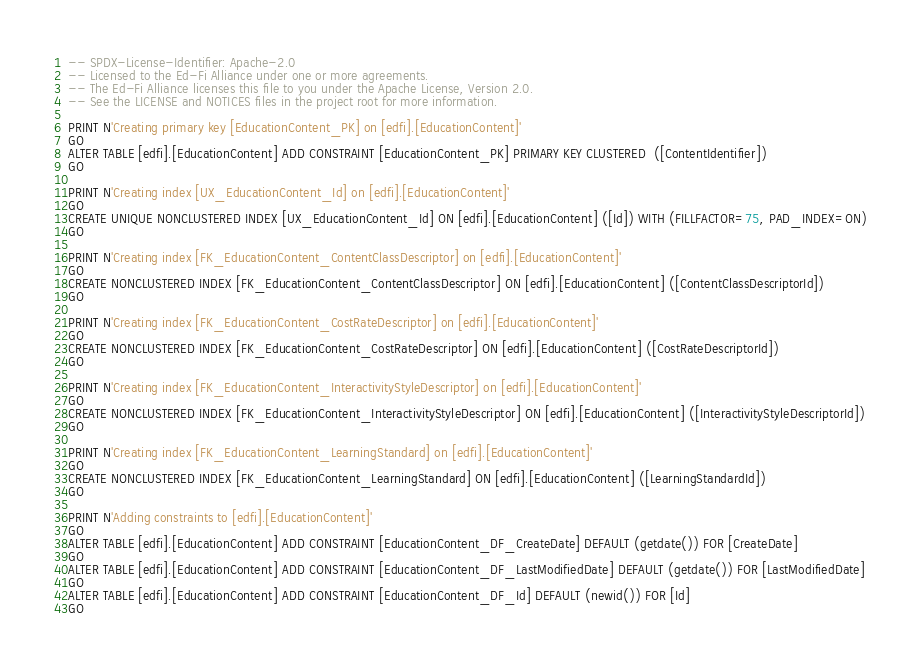Convert code to text. <code><loc_0><loc_0><loc_500><loc_500><_SQL_>-- SPDX-License-Identifier: Apache-2.0
-- Licensed to the Ed-Fi Alliance under one or more agreements.
-- The Ed-Fi Alliance licenses this file to you under the Apache License, Version 2.0.
-- See the LICENSE and NOTICES files in the project root for more information.

PRINT N'Creating primary key [EducationContent_PK] on [edfi].[EducationContent]'
GO
ALTER TABLE [edfi].[EducationContent] ADD CONSTRAINT [EducationContent_PK] PRIMARY KEY CLUSTERED  ([ContentIdentifier])
GO

PRINT N'Creating index [UX_EducationContent_Id] on [edfi].[EducationContent]'
GO
CREATE UNIQUE NONCLUSTERED INDEX [UX_EducationContent_Id] ON [edfi].[EducationContent] ([Id]) WITH (FILLFACTOR=75, PAD_INDEX=ON)
GO

PRINT N'Creating index [FK_EducationContent_ContentClassDescriptor] on [edfi].[EducationContent]'
GO
CREATE NONCLUSTERED INDEX [FK_EducationContent_ContentClassDescriptor] ON [edfi].[EducationContent] ([ContentClassDescriptorId])
GO

PRINT N'Creating index [FK_EducationContent_CostRateDescriptor] on [edfi].[EducationContent]'
GO
CREATE NONCLUSTERED INDEX [FK_EducationContent_CostRateDescriptor] ON [edfi].[EducationContent] ([CostRateDescriptorId])
GO

PRINT N'Creating index [FK_EducationContent_InteractivityStyleDescriptor] on [edfi].[EducationContent]'
GO
CREATE NONCLUSTERED INDEX [FK_EducationContent_InteractivityStyleDescriptor] ON [edfi].[EducationContent] ([InteractivityStyleDescriptorId])
GO

PRINT N'Creating index [FK_EducationContent_LearningStandard] on [edfi].[EducationContent]'
GO
CREATE NONCLUSTERED INDEX [FK_EducationContent_LearningStandard] ON [edfi].[EducationContent] ([LearningStandardId])
GO

PRINT N'Adding constraints to [edfi].[EducationContent]'
GO
ALTER TABLE [edfi].[EducationContent] ADD CONSTRAINT [EducationContent_DF_CreateDate] DEFAULT (getdate()) FOR [CreateDate]
GO
ALTER TABLE [edfi].[EducationContent] ADD CONSTRAINT [EducationContent_DF_LastModifiedDate] DEFAULT (getdate()) FOR [LastModifiedDate]
GO
ALTER TABLE [edfi].[EducationContent] ADD CONSTRAINT [EducationContent_DF_Id] DEFAULT (newid()) FOR [Id]
GO
</code> 